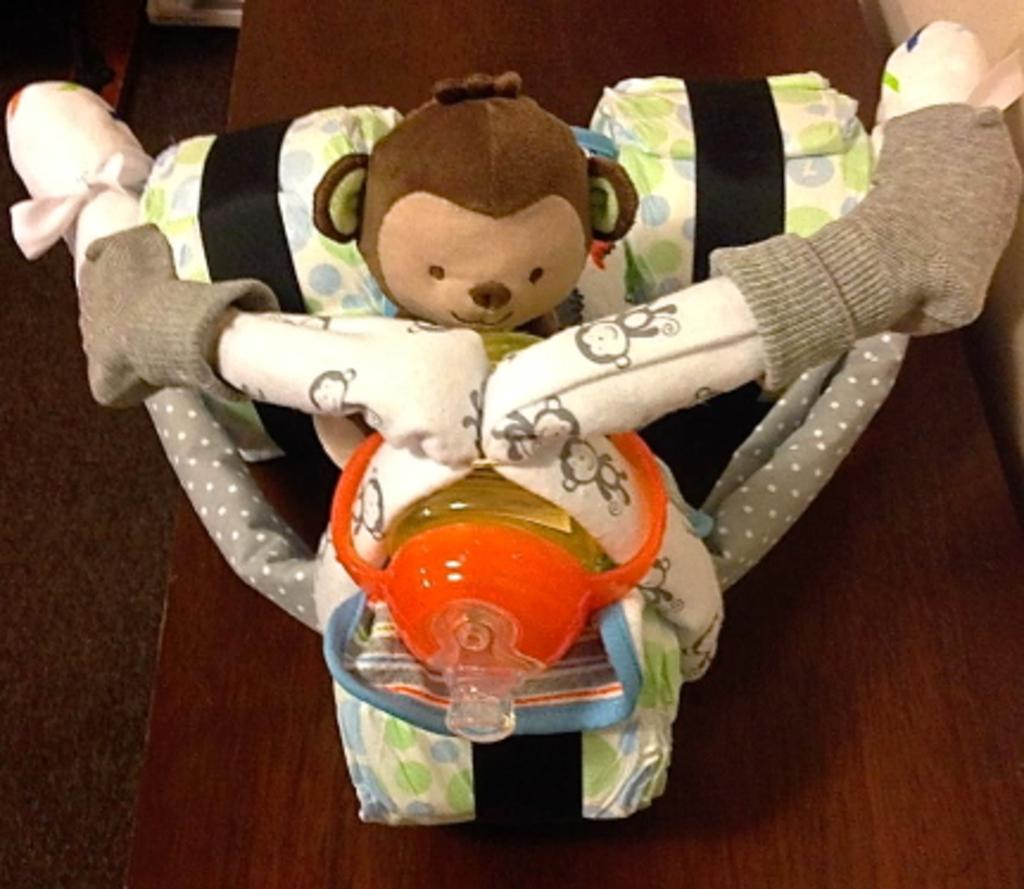What type of object can be seen in the image? There is a soft toy in the image. What else is present in the image? There is a bottle in the image. How many houses are visible in the image? There are no houses present in the image. What type of animal is grazing in the background of the image? There is no animal, such as a cow or sheep, present in the image. 